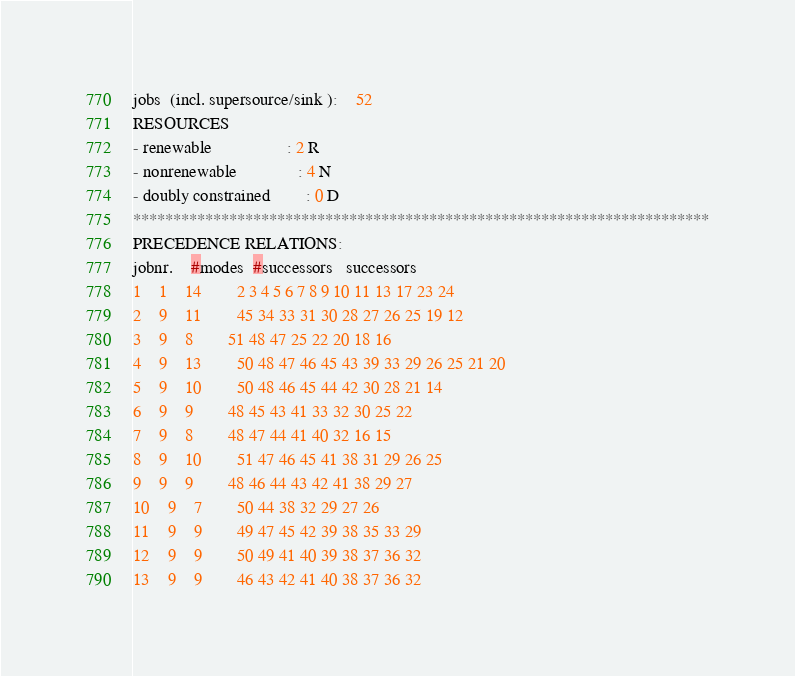<code> <loc_0><loc_0><loc_500><loc_500><_ObjectiveC_>jobs  (incl. supersource/sink ):	52
RESOURCES
- renewable                 : 2 R
- nonrenewable              : 4 N
- doubly constrained        : 0 D
************************************************************************
PRECEDENCE RELATIONS:
jobnr.    #modes  #successors   successors
1	1	14		2 3 4 5 6 7 8 9 10 11 13 17 23 24 
2	9	11		45 34 33 31 30 28 27 26 25 19 12 
3	9	8		51 48 47 25 22 20 18 16 
4	9	13		50 48 47 46 45 43 39 33 29 26 25 21 20 
5	9	10		50 48 46 45 44 42 30 28 21 14 
6	9	9		48 45 43 41 33 32 30 25 22 
7	9	8		48 47 44 41 40 32 16 15 
8	9	10		51 47 46 45 41 38 31 29 26 25 
9	9	9		48 46 44 43 42 41 38 29 27 
10	9	7		50 44 38 32 29 27 26 
11	9	9		49 47 45 42 39 38 35 33 29 
12	9	9		50 49 41 40 39 38 37 36 32 
13	9	9		46 43 42 41 40 38 37 36 32 </code> 